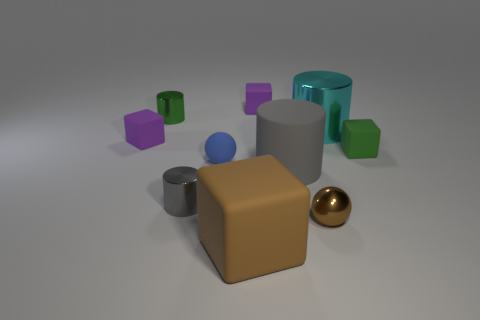Is the shape of the small brown thing the same as the blue matte thing?
Offer a very short reply. Yes. What number of rubber things are either brown balls or green cylinders?
Give a very brief answer. 0. Is there a blue cylinder of the same size as the brown metallic sphere?
Your response must be concise. No. The thing that is the same color as the large block is what shape?
Offer a very short reply. Sphere. How many green metallic things are the same size as the rubber sphere?
Your answer should be very brief. 1. There is a purple block behind the cyan metal cylinder; is its size the same as the gray object on the right side of the big brown rubber object?
Provide a succinct answer. No. What number of objects are small matte balls or shiny things that are to the right of the gray matte cylinder?
Give a very brief answer. 3. The large metal object is what color?
Keep it short and to the point. Cyan. What is the purple block that is behind the big cyan cylinder that is in front of the cylinder behind the cyan metal object made of?
Make the answer very short. Rubber. The green object that is the same material as the tiny brown object is what size?
Offer a terse response. Small. 